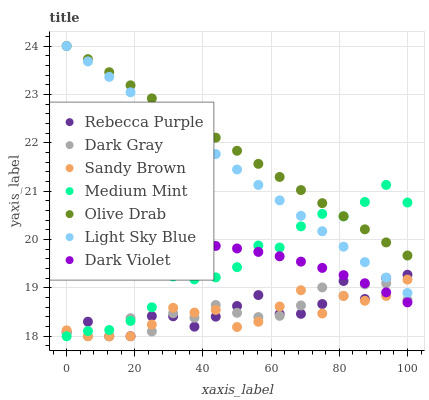Does Sandy Brown have the minimum area under the curve?
Answer yes or no. Yes. Does Olive Drab have the maximum area under the curve?
Answer yes or no. Yes. Does Dark Violet have the minimum area under the curve?
Answer yes or no. No. Does Dark Violet have the maximum area under the curve?
Answer yes or no. No. Is Light Sky Blue the smoothest?
Answer yes or no. Yes. Is Rebecca Purple the roughest?
Answer yes or no. Yes. Is Dark Violet the smoothest?
Answer yes or no. No. Is Dark Violet the roughest?
Answer yes or no. No. Does Medium Mint have the lowest value?
Answer yes or no. Yes. Does Dark Violet have the lowest value?
Answer yes or no. No. Does Olive Drab have the highest value?
Answer yes or no. Yes. Does Dark Violet have the highest value?
Answer yes or no. No. Is Dark Gray less than Light Sky Blue?
Answer yes or no. Yes. Is Olive Drab greater than Rebecca Purple?
Answer yes or no. Yes. Does Light Sky Blue intersect Sandy Brown?
Answer yes or no. Yes. Is Light Sky Blue less than Sandy Brown?
Answer yes or no. No. Is Light Sky Blue greater than Sandy Brown?
Answer yes or no. No. Does Dark Gray intersect Light Sky Blue?
Answer yes or no. No. 